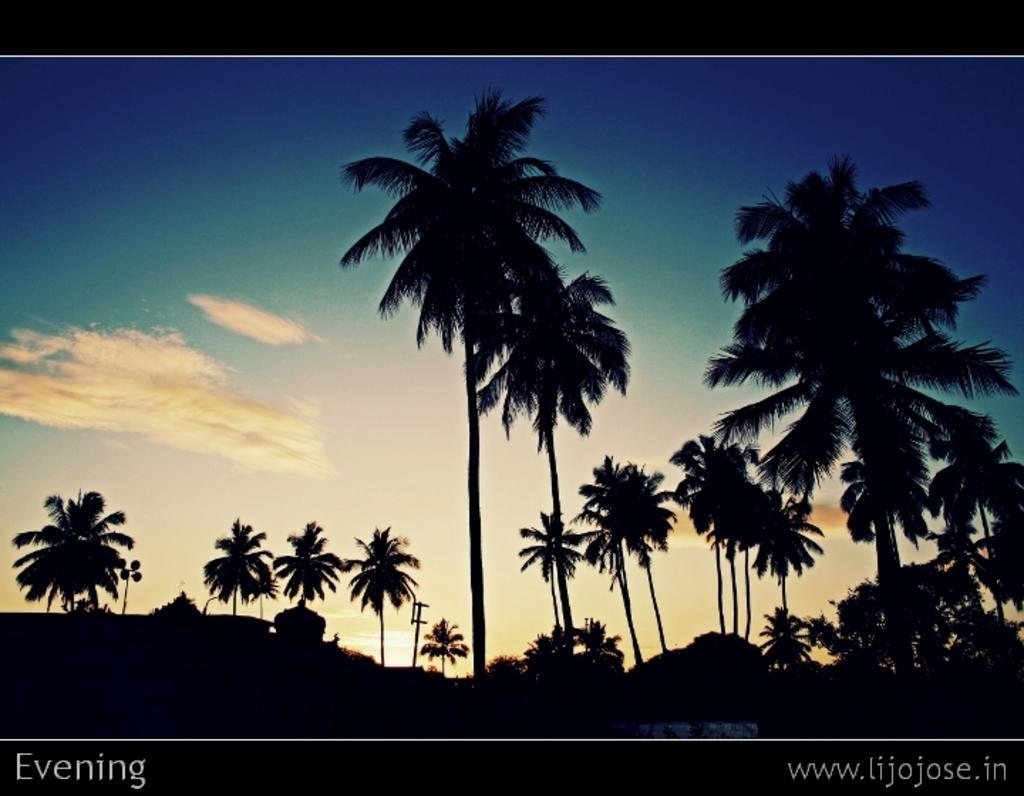How would you summarize this image in a sentence or two? In this image I can see number of trees and a view of sky. 